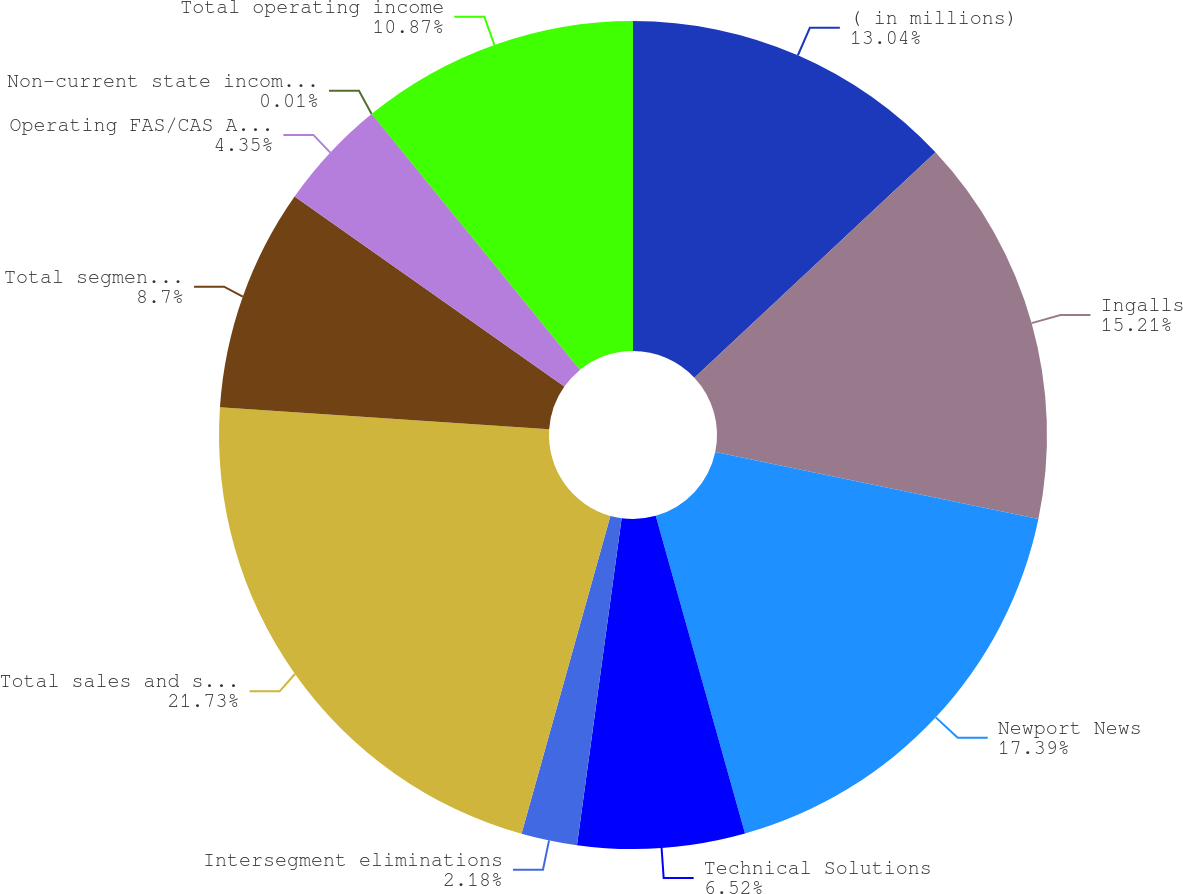<chart> <loc_0><loc_0><loc_500><loc_500><pie_chart><fcel>( in millions)<fcel>Ingalls<fcel>Newport News<fcel>Technical Solutions<fcel>Intersegment eliminations<fcel>Total sales and service<fcel>Total segment operating income<fcel>Operating FAS/CAS Adjustment<fcel>Non-current state income taxes<fcel>Total operating income<nl><fcel>13.04%<fcel>15.21%<fcel>17.39%<fcel>6.52%<fcel>2.18%<fcel>21.73%<fcel>8.7%<fcel>4.35%<fcel>0.01%<fcel>10.87%<nl></chart> 